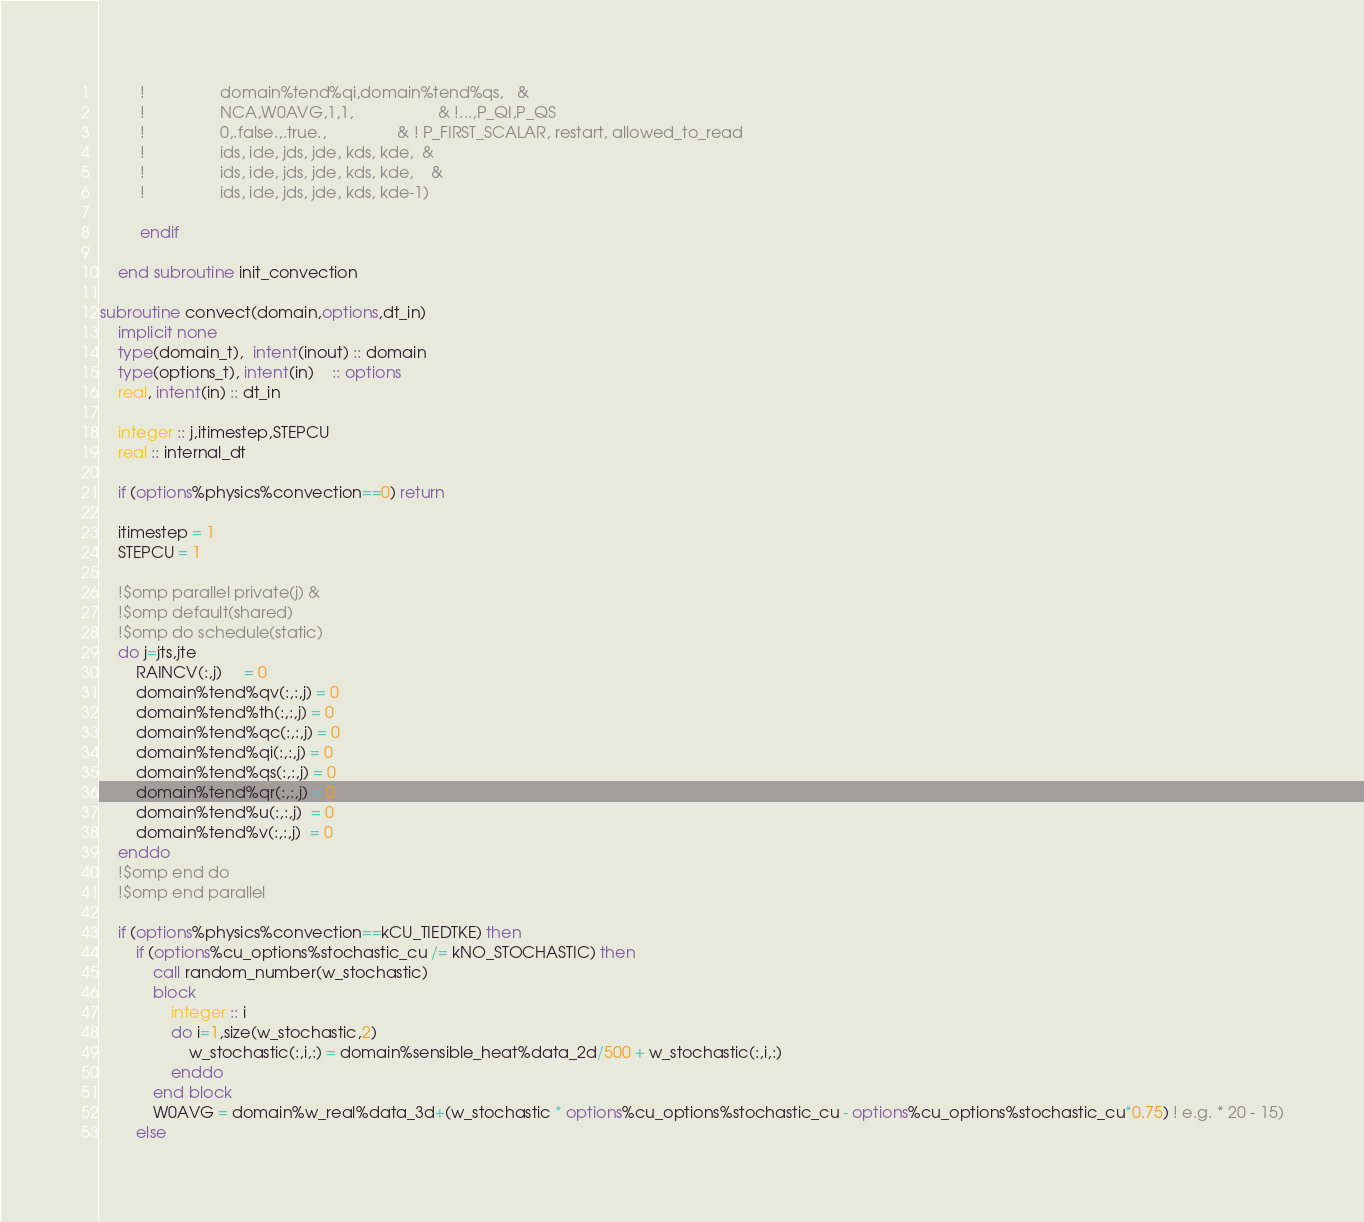<code> <loc_0><loc_0><loc_500><loc_500><_FORTRAN_>         !                 domain%tend%qi,domain%tend%qs,   &
         !                 NCA,W0AVG,1,1,                   & !...,P_QI,P_QS
         !                 0,.false.,.true.,                & ! P_FIRST_SCALAR, restart, allowed_to_read
         !                 ids, ide, jds, jde, kds, kde,  &
         !                 ids, ide, jds, jde, kds, kde,    &
         !                 ids, ide, jds, jde, kds, kde-1)

         endif

    end subroutine init_convection

subroutine convect(domain,options,dt_in)
    implicit none
    type(domain_t),  intent(inout) :: domain
    type(options_t), intent(in)    :: options
    real, intent(in) :: dt_in

    integer :: j,itimestep,STEPCU
    real :: internal_dt

    if (options%physics%convection==0) return

    itimestep = 1
    STEPCU = 1

    !$omp parallel private(j) &
    !$omp default(shared)
    !$omp do schedule(static)
    do j=jts,jte
        RAINCV(:,j)     = 0
        domain%tend%qv(:,:,j) = 0
        domain%tend%th(:,:,j) = 0
        domain%tend%qc(:,:,j) = 0
        domain%tend%qi(:,:,j) = 0
        domain%tend%qs(:,:,j) = 0
        domain%tend%qr(:,:,j) = 0
        domain%tend%u(:,:,j)  = 0
        domain%tend%v(:,:,j)  = 0
    enddo
    !$omp end do
    !$omp end parallel

    if (options%physics%convection==kCU_TIEDTKE) then
        if (options%cu_options%stochastic_cu /= kNO_STOCHASTIC) then
            call random_number(w_stochastic)
            block
                integer :: i
                do i=1,size(w_stochastic,2)
                    w_stochastic(:,i,:) = domain%sensible_heat%data_2d/500 + w_stochastic(:,i,:)
                enddo
            end block
            W0AVG = domain%w_real%data_3d+(w_stochastic * options%cu_options%stochastic_cu - options%cu_options%stochastic_cu*0.75) ! e.g. * 20 - 15)
        else</code> 